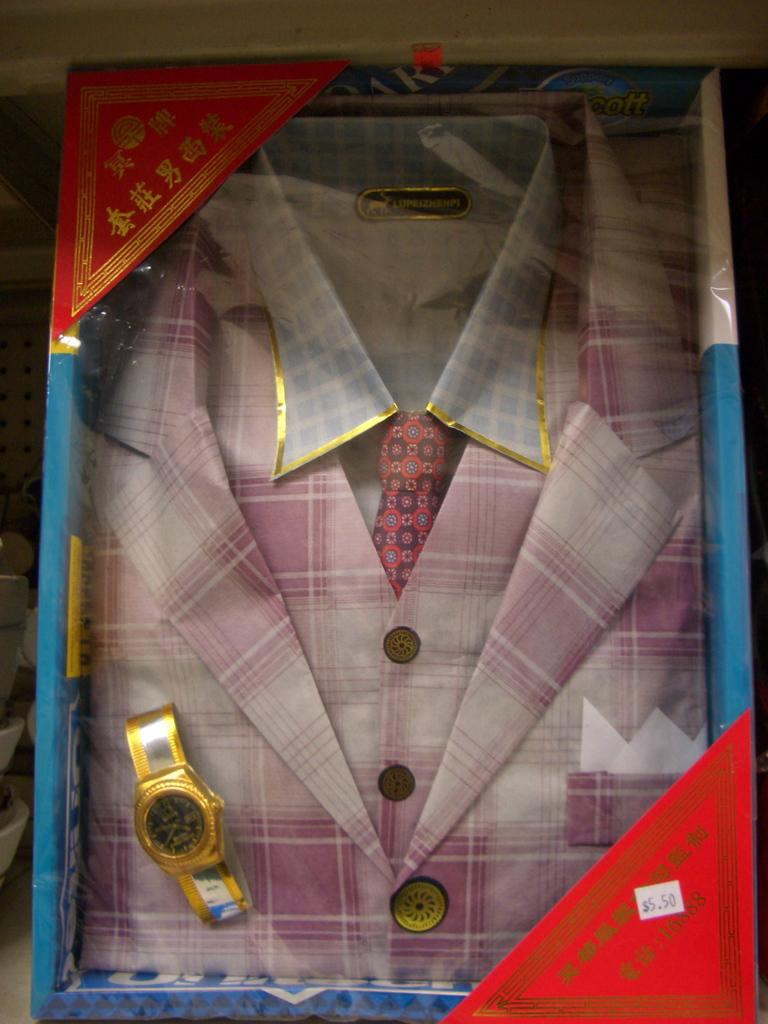<image>
Give a short and clear explanation of the subsequent image. A price tag for 5.50 is on a package with clothing and a watch. 